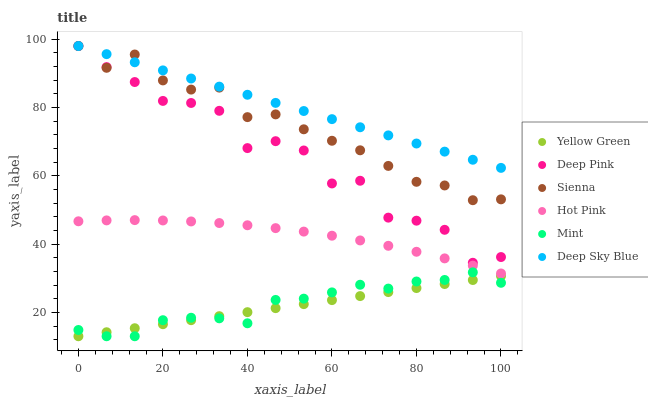Does Yellow Green have the minimum area under the curve?
Answer yes or no. Yes. Does Deep Sky Blue have the maximum area under the curve?
Answer yes or no. Yes. Does Hot Pink have the minimum area under the curve?
Answer yes or no. No. Does Hot Pink have the maximum area under the curve?
Answer yes or no. No. Is Yellow Green the smoothest?
Answer yes or no. Yes. Is Deep Pink the roughest?
Answer yes or no. Yes. Is Hot Pink the smoothest?
Answer yes or no. No. Is Hot Pink the roughest?
Answer yes or no. No. Does Yellow Green have the lowest value?
Answer yes or no. Yes. Does Hot Pink have the lowest value?
Answer yes or no. No. Does Deep Sky Blue have the highest value?
Answer yes or no. Yes. Does Hot Pink have the highest value?
Answer yes or no. No. Is Hot Pink less than Deep Pink?
Answer yes or no. Yes. Is Hot Pink greater than Mint?
Answer yes or no. Yes. Does Mint intersect Yellow Green?
Answer yes or no. Yes. Is Mint less than Yellow Green?
Answer yes or no. No. Is Mint greater than Yellow Green?
Answer yes or no. No. Does Hot Pink intersect Deep Pink?
Answer yes or no. No. 